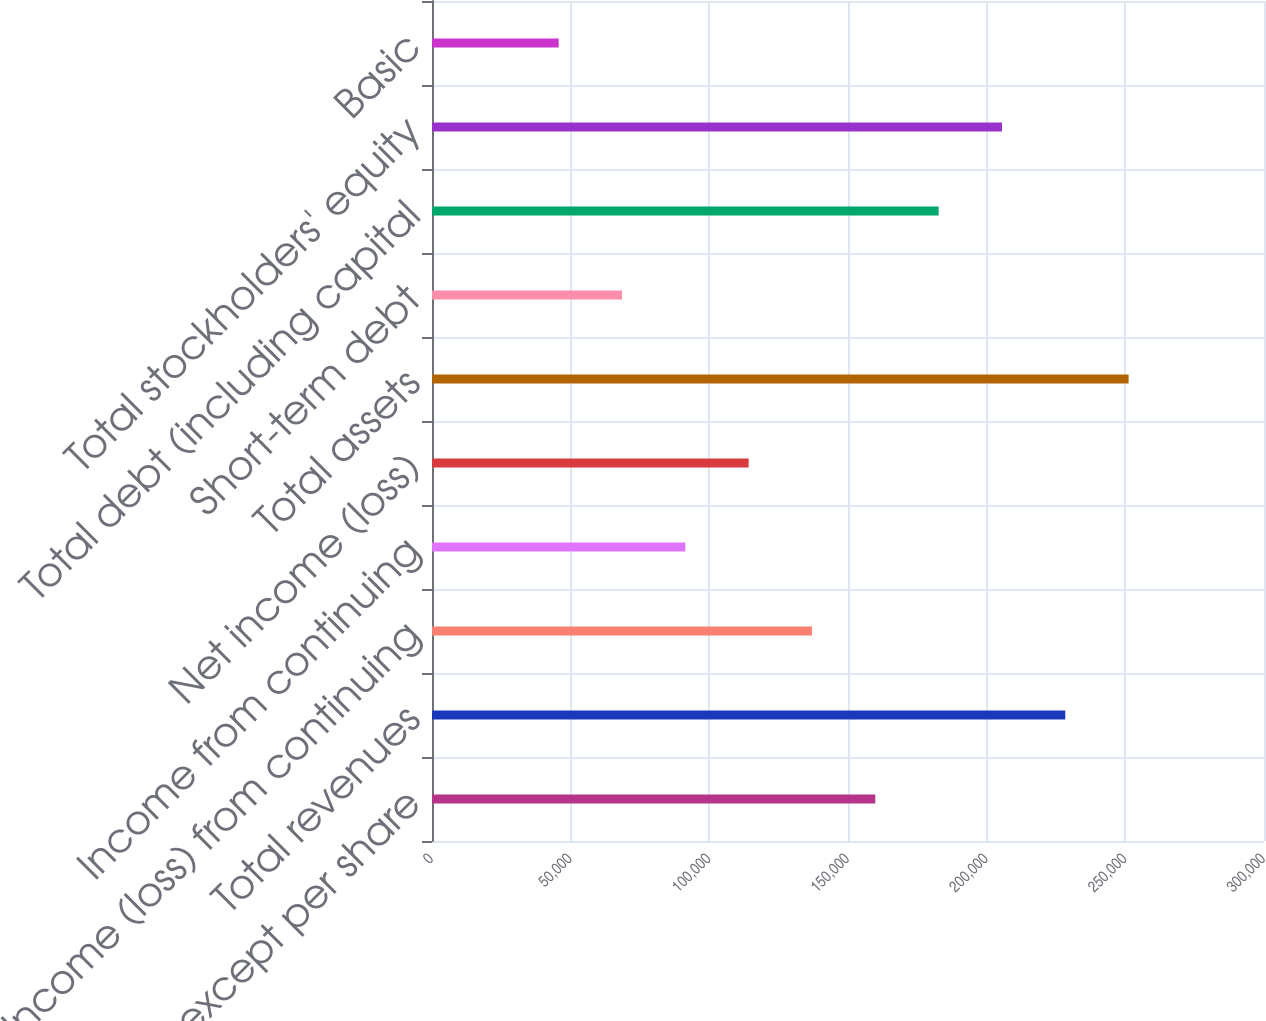Convert chart to OTSL. <chart><loc_0><loc_0><loc_500><loc_500><bar_chart><fcel>in millions except per share<fcel>Total revenues<fcel>Income (loss) from continuing<fcel>Income from continuing<fcel>Net income (loss)<fcel>Total assets<fcel>Short-term debt<fcel>Total debt (including capital<fcel>Total stockholders' equity<fcel>Basic<nl><fcel>159844<fcel>228348<fcel>137009<fcel>91339.7<fcel>114174<fcel>251183<fcel>68504.9<fcel>182679<fcel>205513<fcel>45670.2<nl></chart> 